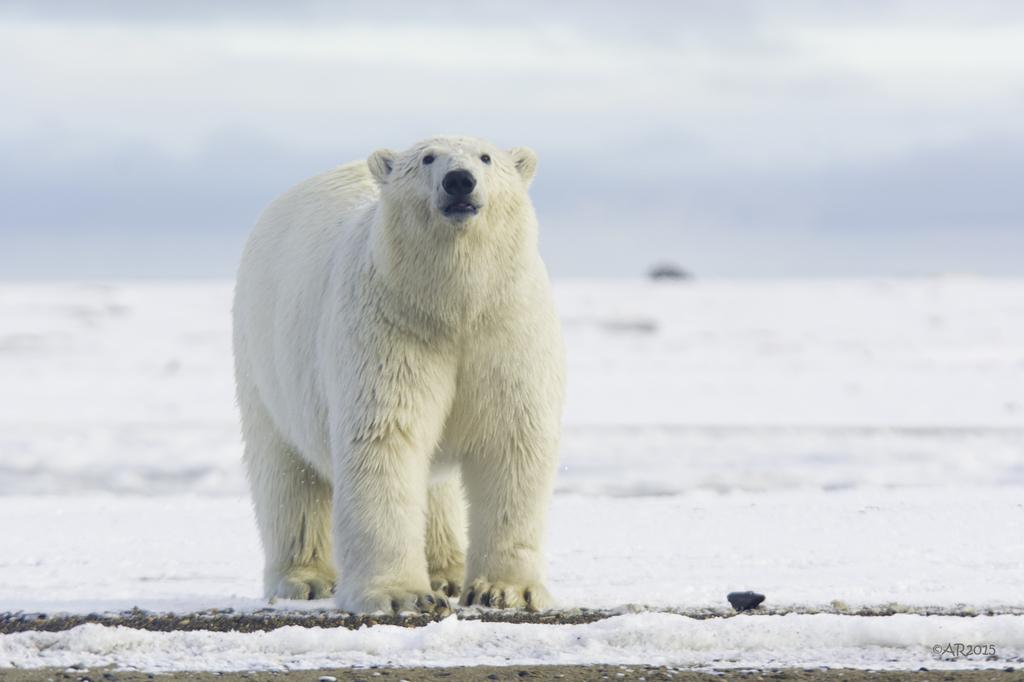What animal is present in the image? There is a polar bear in the image. What type of environment is depicted in the image? The image shows snow, which suggests a cold or icy environment. How many jars of honey are stored near the polar bear in the image? There are no jars of honey present in the image. What type of wealth is depicted in the image? The image does not depict any form of wealth; it features a polar bear in a snowy environment. 